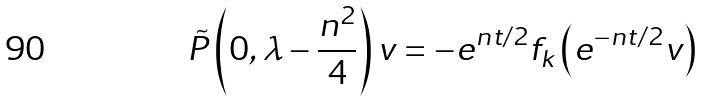Convert formula to latex. <formula><loc_0><loc_0><loc_500><loc_500>\tilde { P } \left ( 0 , \lambda - \frac { n ^ { 2 } } { 4 } \right ) v = - e ^ { n t / 2 } f _ { k } \left ( e ^ { - n t / 2 } v \right )</formula> 